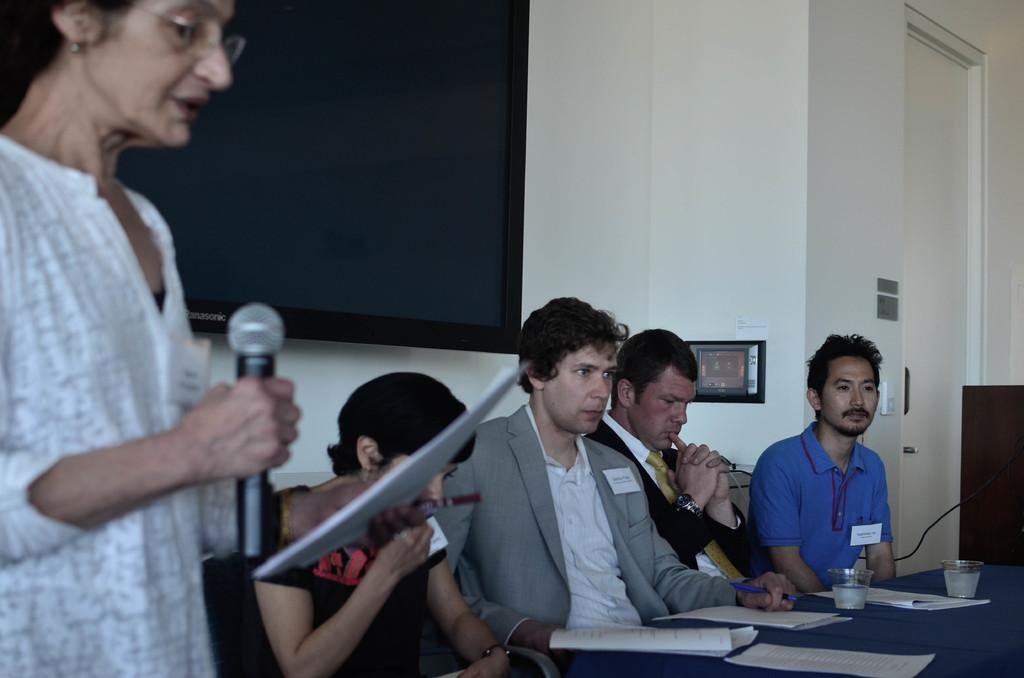What are the people in the image doing? The people in the image are sitting on chairs. What is the woman in the image doing? The woman is standing and holding a mic in her hand. How far can the boy in the image see from the jail? There is no boy or jail present in the image. 